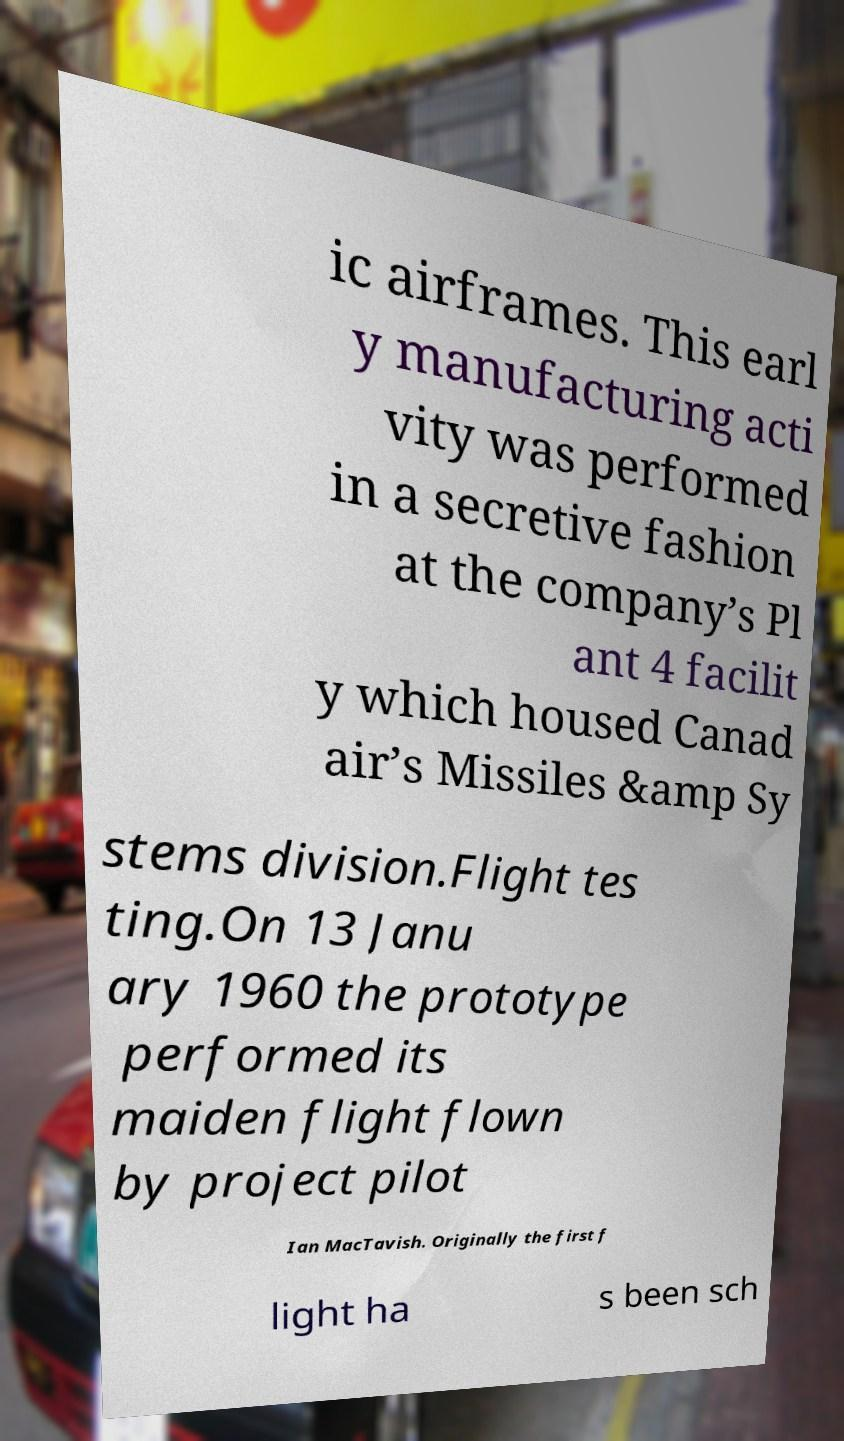Can you read and provide the text displayed in the image?This photo seems to have some interesting text. Can you extract and type it out for me? ic airframes. This earl y manufacturing acti vity was performed in a secretive fashion at the company’s Pl ant 4 facilit y which housed Canad air’s Missiles &amp Sy stems division.Flight tes ting.On 13 Janu ary 1960 the prototype performed its maiden flight flown by project pilot Ian MacTavish. Originally the first f light ha s been sch 